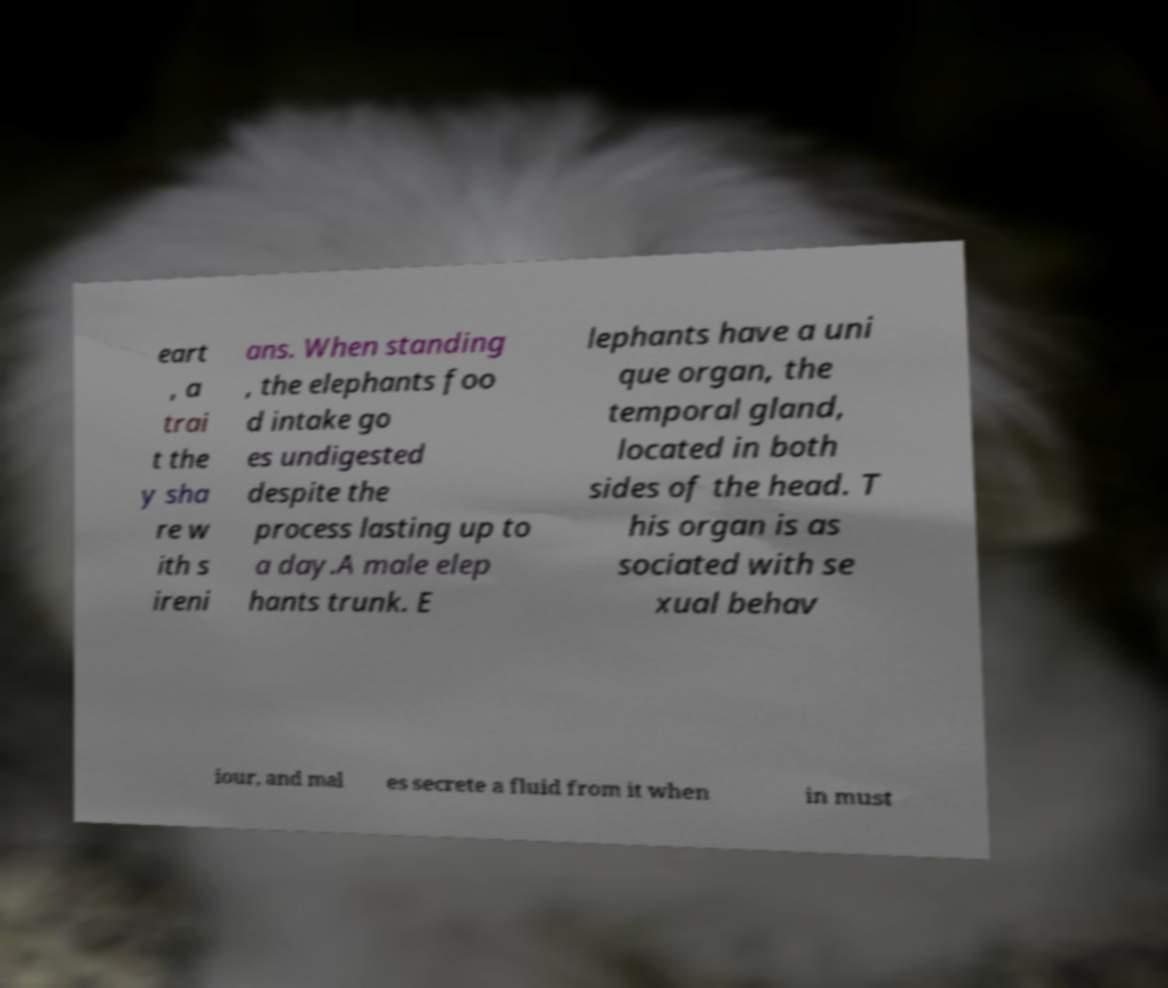Can you accurately transcribe the text from the provided image for me? eart , a trai t the y sha re w ith s ireni ans. When standing , the elephants foo d intake go es undigested despite the process lasting up to a day.A male elep hants trunk. E lephants have a uni que organ, the temporal gland, located in both sides of the head. T his organ is as sociated with se xual behav iour, and mal es secrete a fluid from it when in must 